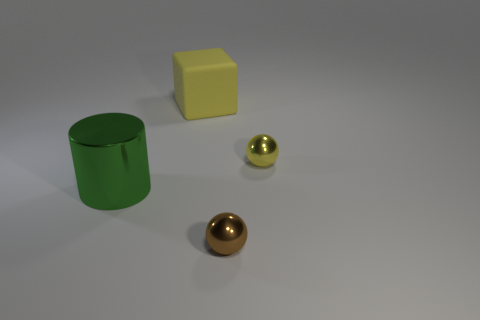Add 3 tiny yellow objects. How many objects exist? 7 Subtract all blocks. How many objects are left? 3 Add 1 yellow cubes. How many yellow cubes are left? 2 Add 2 large matte blocks. How many large matte blocks exist? 3 Subtract 0 purple spheres. How many objects are left? 4 Subtract all large metal things. Subtract all yellow metallic objects. How many objects are left? 2 